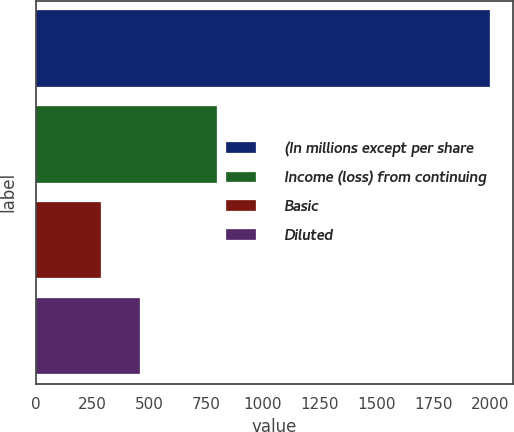Convert chart to OTSL. <chart><loc_0><loc_0><loc_500><loc_500><bar_chart><fcel>(In millions except per share<fcel>Income (loss) from continuing<fcel>Basic<fcel>Diluted<nl><fcel>2002<fcel>800.24<fcel>285.2<fcel>456.88<nl></chart> 